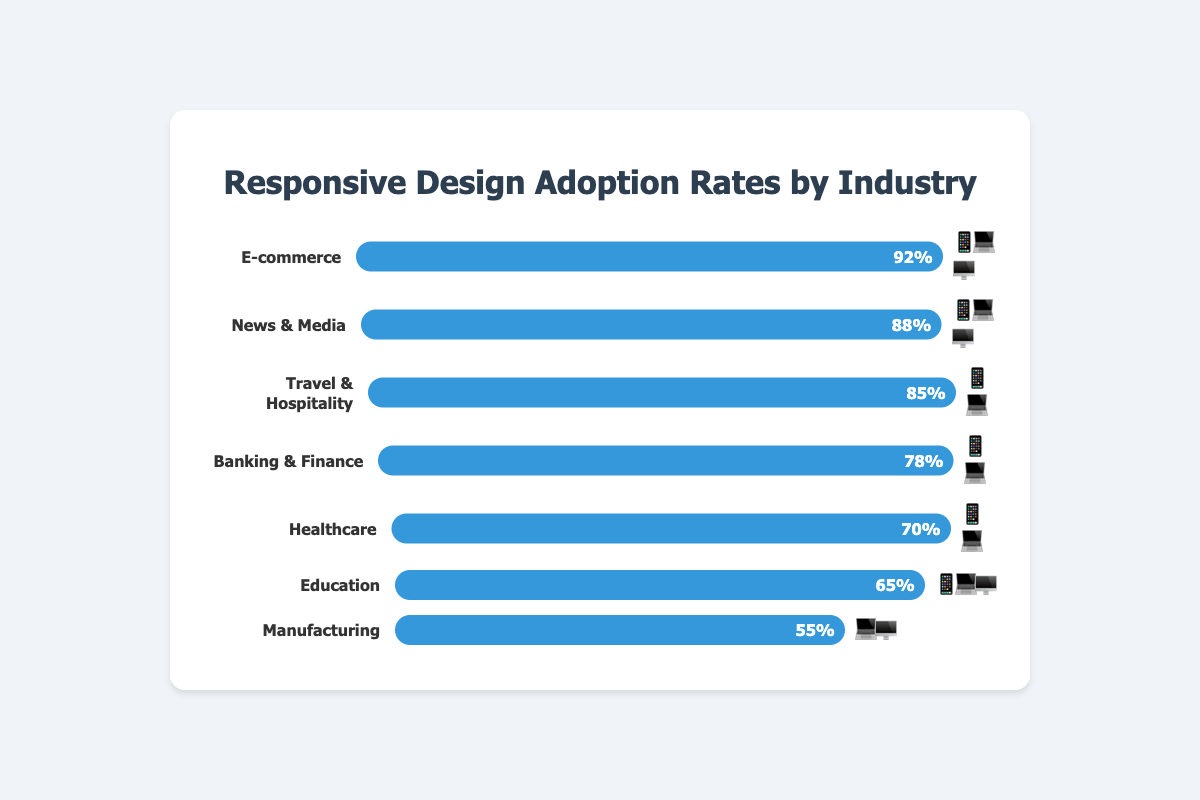What is the adoption rate of responsive design in the Healthcare industry? The bar for the Healthcare industry shows an adoption rate of 70%.
Answer: 70% Which industry has the highest adoption rate, and what is it? The E-commerce industry shows the highest adoption rate with 92% as indicated by the longest bar filled to 92% on the chart.
Answer: E-commerce at 92% Which industry references only two devices in its emoji representation? The industries with only two devices emoji representation are Travel & Hospitality, Banking & Finance, and Healthcare.
Answer: Travel & Hospitality, Banking & Finance, Healthcare What is the difference in adoption rates between the News & Media industry and the Manufacturing industry? The News & Media industry has an adoption rate of 88%, and Manufacturing has an adoption rate of 55%. Subtract 55 from 88 to get the difference.
Answer: 33% Rank the industries from highest to lowest in terms of adoption rate. E-commerce (92%), News & Media (88%), Travel & Hospitality (85%), Banking & Finance (78%), Healthcare (70%), Education (65%), Manufacturing (55%).
Answer: E-commerce, News & Media, Travel & Hospitality, Banking & Finance, Healthcare, Education, Manufacturing What is the total adoption rate percentage for all industries combined? Add up the adoption rates: 92 + 88 + 85 + 78 + 70 + 65 + 55 = 533%.
Answer: 533% Which industries are using all three device types (📱💻🖥️)? The E-commerce, News & Media, and Education industries use all three device icons 📱💻🖥️ in their representation.
Answer: E-commerce, News & Media, Education What is the average adoption rate of all industries showcased in the figure? Calculate the average by summing the adoption rates of all industries (533) and dividing by the number of industries (7). So, 533/7 = 76.14.
Answer: 76.14% Compare the adoption rates of Education and Healthcare industries. Which is higher and by how much? The Education industry has an adoption rate of 65%, while Healthcare has 70%. Subtract 65 from 70 to find the difference. Healthcare has a higher rate by 5%.
Answer: Healthcare by 5% Which industry has the least adoption rate and what is the value? The Manufacturing industry has the least adoption rate shown by the shortest bar, which is 55%.
Answer: Manufacturing at 55% 